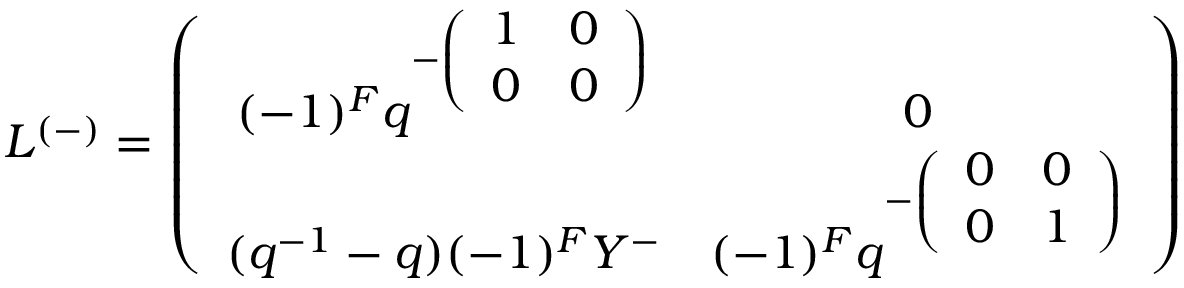<formula> <loc_0><loc_0><loc_500><loc_500>L ^ { ( - ) } = \left ( \begin{array} { c c } { { ( - 1 ) ^ { F } q ^ { - \left ( \begin{array} { c c } { 1 } & { 0 } \\ { 0 } & { 0 } \end{array} \right ) } } } & { 0 } \\ { { ( q ^ { - 1 } - q ) ( - 1 ) ^ { F } Y ^ { - } } } & { { ( - 1 ) ^ { F } q ^ { - \left ( \begin{array} { c c } { 0 } & { 0 } \\ { 0 } & { 1 } \end{array} \right ) } } } \end{array} \right )</formula> 